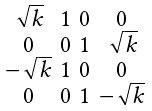Convert formula to latex. <formula><loc_0><loc_0><loc_500><loc_500>\begin{smallmatrix} \sqrt { k } & 1 & 0 & 0 \\ 0 & 0 & 1 & \sqrt { k } \\ - \sqrt { k } & 1 & 0 & 0 \\ 0 & 0 & 1 & - \sqrt { k } \end{smallmatrix}</formula> 